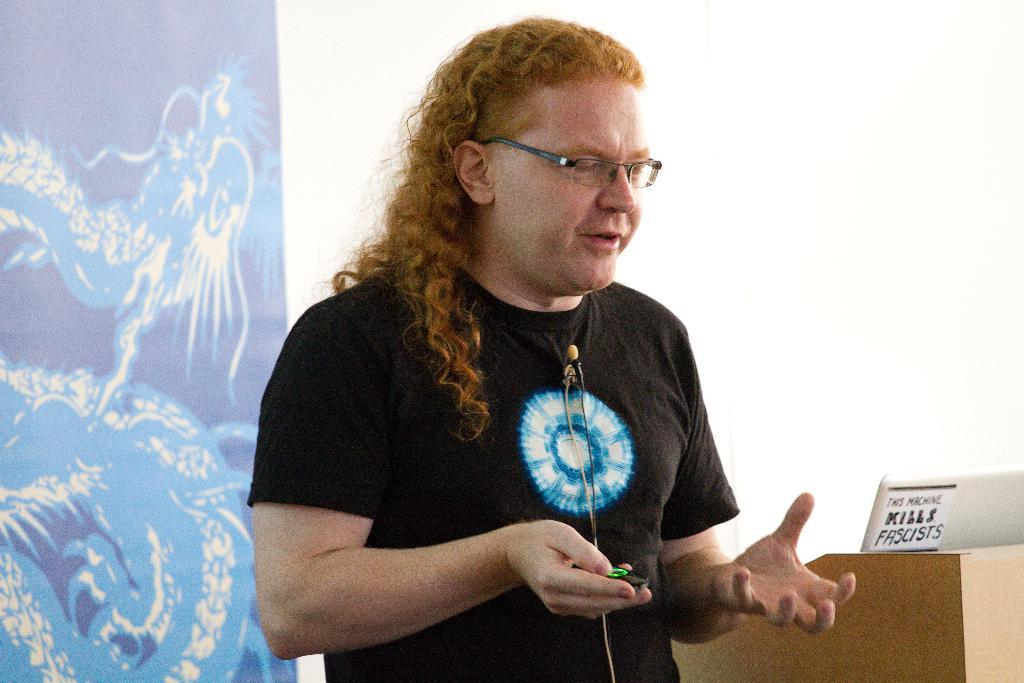What is the man in the image doing? The man is standing in the image. What is the man holding in the image? The man is holding an object. Can you describe the man's appearance? The man is wearing spectacles. What can be seen on the podium in the image? There is a laptop on a podium in the image. What is visible in the background of the image? There is a screen in the background of the image. What is the color of the screen? The screen is white in color. What type of gold can be seen in the image? There is no gold present in the image. How much coal is visible in the image? There is no coal present in the image. 